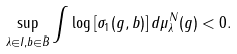<formula> <loc_0><loc_0><loc_500><loc_500>\sup _ { \lambda \in I , b \in \tilde { B } } \int \log \left [ \sigma _ { 1 } ( g , b ) \right ] d \mu _ { \lambda } ^ { N } ( g ) < 0 .</formula> 